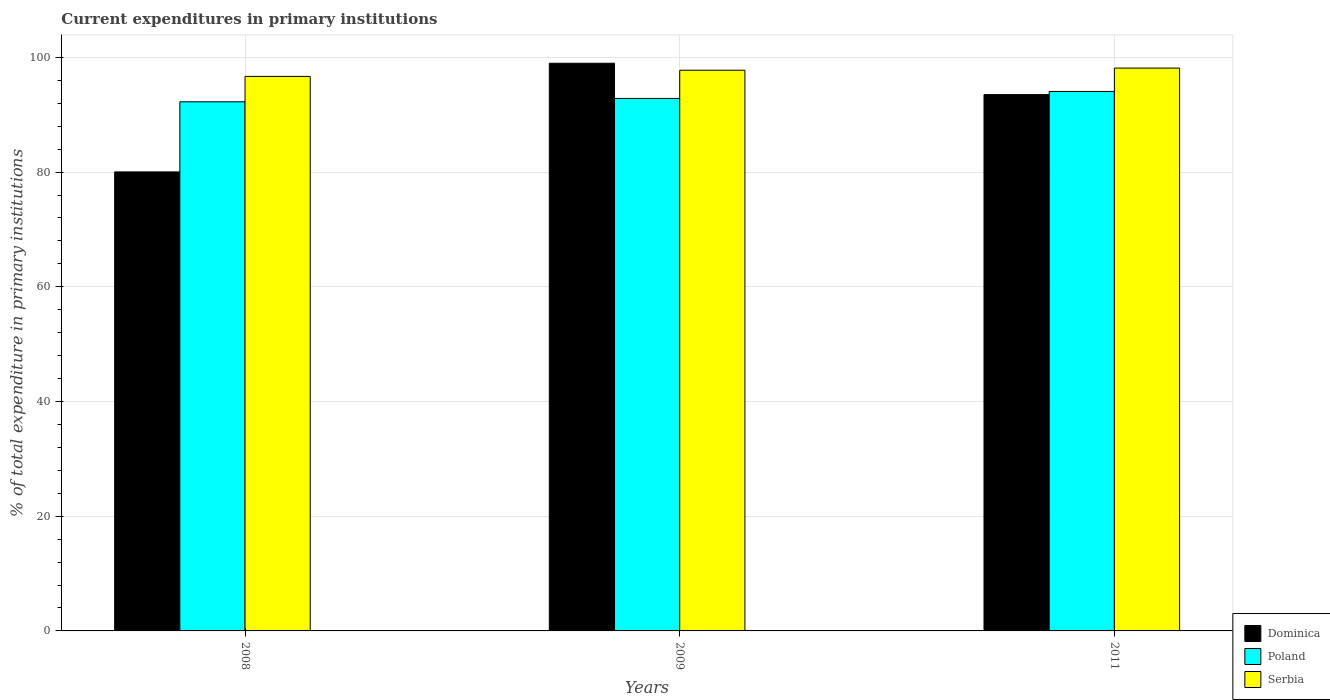How many groups of bars are there?
Your response must be concise. 3. Are the number of bars per tick equal to the number of legend labels?
Keep it short and to the point. Yes. Are the number of bars on each tick of the X-axis equal?
Offer a terse response. Yes. What is the label of the 2nd group of bars from the left?
Keep it short and to the point. 2009. What is the current expenditures in primary institutions in Serbia in 2011?
Offer a very short reply. 98.13. Across all years, what is the maximum current expenditures in primary institutions in Serbia?
Give a very brief answer. 98.13. Across all years, what is the minimum current expenditures in primary institutions in Serbia?
Provide a succinct answer. 96.68. In which year was the current expenditures in primary institutions in Poland maximum?
Make the answer very short. 2011. What is the total current expenditures in primary institutions in Serbia in the graph?
Give a very brief answer. 292.57. What is the difference between the current expenditures in primary institutions in Serbia in 2008 and that in 2011?
Give a very brief answer. -1.45. What is the difference between the current expenditures in primary institutions in Serbia in 2011 and the current expenditures in primary institutions in Poland in 2009?
Give a very brief answer. 5.29. What is the average current expenditures in primary institutions in Serbia per year?
Make the answer very short. 97.52. In the year 2009, what is the difference between the current expenditures in primary institutions in Serbia and current expenditures in primary institutions in Dominica?
Offer a very short reply. -1.22. In how many years, is the current expenditures in primary institutions in Poland greater than 76 %?
Ensure brevity in your answer.  3. What is the ratio of the current expenditures in primary institutions in Poland in 2009 to that in 2011?
Your answer should be compact. 0.99. What is the difference between the highest and the second highest current expenditures in primary institutions in Serbia?
Your response must be concise. 0.37. What is the difference between the highest and the lowest current expenditures in primary institutions in Poland?
Your response must be concise. 1.8. In how many years, is the current expenditures in primary institutions in Poland greater than the average current expenditures in primary institutions in Poland taken over all years?
Your answer should be very brief. 1. What does the 3rd bar from the left in 2008 represents?
Your answer should be compact. Serbia. What does the 1st bar from the right in 2008 represents?
Provide a succinct answer. Serbia. How many years are there in the graph?
Give a very brief answer. 3. Does the graph contain any zero values?
Ensure brevity in your answer.  No. Where does the legend appear in the graph?
Offer a terse response. Bottom right. What is the title of the graph?
Keep it short and to the point. Current expenditures in primary institutions. What is the label or title of the Y-axis?
Offer a very short reply. % of total expenditure in primary institutions. What is the % of total expenditure in primary institutions in Dominica in 2008?
Make the answer very short. 80.03. What is the % of total expenditure in primary institutions in Poland in 2008?
Give a very brief answer. 92.25. What is the % of total expenditure in primary institutions of Serbia in 2008?
Ensure brevity in your answer.  96.68. What is the % of total expenditure in primary institutions in Dominica in 2009?
Your response must be concise. 98.97. What is the % of total expenditure in primary institutions of Poland in 2009?
Offer a terse response. 92.84. What is the % of total expenditure in primary institutions in Serbia in 2009?
Provide a short and direct response. 97.76. What is the % of total expenditure in primary institutions of Dominica in 2011?
Offer a very short reply. 93.5. What is the % of total expenditure in primary institutions of Poland in 2011?
Your response must be concise. 94.06. What is the % of total expenditure in primary institutions in Serbia in 2011?
Ensure brevity in your answer.  98.13. Across all years, what is the maximum % of total expenditure in primary institutions of Dominica?
Make the answer very short. 98.97. Across all years, what is the maximum % of total expenditure in primary institutions of Poland?
Offer a terse response. 94.06. Across all years, what is the maximum % of total expenditure in primary institutions in Serbia?
Keep it short and to the point. 98.13. Across all years, what is the minimum % of total expenditure in primary institutions of Dominica?
Your answer should be very brief. 80.03. Across all years, what is the minimum % of total expenditure in primary institutions of Poland?
Provide a succinct answer. 92.25. Across all years, what is the minimum % of total expenditure in primary institutions of Serbia?
Give a very brief answer. 96.68. What is the total % of total expenditure in primary institutions in Dominica in the graph?
Keep it short and to the point. 272.5. What is the total % of total expenditure in primary institutions in Poland in the graph?
Your answer should be compact. 279.15. What is the total % of total expenditure in primary institutions of Serbia in the graph?
Keep it short and to the point. 292.57. What is the difference between the % of total expenditure in primary institutions of Dominica in 2008 and that in 2009?
Make the answer very short. -18.94. What is the difference between the % of total expenditure in primary institutions in Poland in 2008 and that in 2009?
Make the answer very short. -0.58. What is the difference between the % of total expenditure in primary institutions in Serbia in 2008 and that in 2009?
Keep it short and to the point. -1.08. What is the difference between the % of total expenditure in primary institutions in Dominica in 2008 and that in 2011?
Keep it short and to the point. -13.48. What is the difference between the % of total expenditure in primary institutions of Poland in 2008 and that in 2011?
Offer a very short reply. -1.8. What is the difference between the % of total expenditure in primary institutions in Serbia in 2008 and that in 2011?
Provide a short and direct response. -1.45. What is the difference between the % of total expenditure in primary institutions in Dominica in 2009 and that in 2011?
Ensure brevity in your answer.  5.47. What is the difference between the % of total expenditure in primary institutions of Poland in 2009 and that in 2011?
Provide a succinct answer. -1.22. What is the difference between the % of total expenditure in primary institutions of Serbia in 2009 and that in 2011?
Give a very brief answer. -0.37. What is the difference between the % of total expenditure in primary institutions of Dominica in 2008 and the % of total expenditure in primary institutions of Poland in 2009?
Provide a short and direct response. -12.81. What is the difference between the % of total expenditure in primary institutions of Dominica in 2008 and the % of total expenditure in primary institutions of Serbia in 2009?
Provide a short and direct response. -17.73. What is the difference between the % of total expenditure in primary institutions of Poland in 2008 and the % of total expenditure in primary institutions of Serbia in 2009?
Keep it short and to the point. -5.5. What is the difference between the % of total expenditure in primary institutions in Dominica in 2008 and the % of total expenditure in primary institutions in Poland in 2011?
Give a very brief answer. -14.03. What is the difference between the % of total expenditure in primary institutions in Dominica in 2008 and the % of total expenditure in primary institutions in Serbia in 2011?
Ensure brevity in your answer.  -18.1. What is the difference between the % of total expenditure in primary institutions in Poland in 2008 and the % of total expenditure in primary institutions in Serbia in 2011?
Offer a very short reply. -5.88. What is the difference between the % of total expenditure in primary institutions in Dominica in 2009 and the % of total expenditure in primary institutions in Poland in 2011?
Ensure brevity in your answer.  4.91. What is the difference between the % of total expenditure in primary institutions in Dominica in 2009 and the % of total expenditure in primary institutions in Serbia in 2011?
Your response must be concise. 0.84. What is the difference between the % of total expenditure in primary institutions in Poland in 2009 and the % of total expenditure in primary institutions in Serbia in 2011?
Your response must be concise. -5.29. What is the average % of total expenditure in primary institutions of Dominica per year?
Your response must be concise. 90.83. What is the average % of total expenditure in primary institutions of Poland per year?
Ensure brevity in your answer.  93.05. What is the average % of total expenditure in primary institutions in Serbia per year?
Provide a short and direct response. 97.52. In the year 2008, what is the difference between the % of total expenditure in primary institutions of Dominica and % of total expenditure in primary institutions of Poland?
Offer a very short reply. -12.22. In the year 2008, what is the difference between the % of total expenditure in primary institutions of Dominica and % of total expenditure in primary institutions of Serbia?
Provide a short and direct response. -16.65. In the year 2008, what is the difference between the % of total expenditure in primary institutions in Poland and % of total expenditure in primary institutions in Serbia?
Provide a succinct answer. -4.43. In the year 2009, what is the difference between the % of total expenditure in primary institutions of Dominica and % of total expenditure in primary institutions of Poland?
Keep it short and to the point. 6.13. In the year 2009, what is the difference between the % of total expenditure in primary institutions in Dominica and % of total expenditure in primary institutions in Serbia?
Provide a short and direct response. 1.22. In the year 2009, what is the difference between the % of total expenditure in primary institutions of Poland and % of total expenditure in primary institutions of Serbia?
Your answer should be compact. -4.92. In the year 2011, what is the difference between the % of total expenditure in primary institutions in Dominica and % of total expenditure in primary institutions in Poland?
Your response must be concise. -0.55. In the year 2011, what is the difference between the % of total expenditure in primary institutions in Dominica and % of total expenditure in primary institutions in Serbia?
Keep it short and to the point. -4.62. In the year 2011, what is the difference between the % of total expenditure in primary institutions of Poland and % of total expenditure in primary institutions of Serbia?
Provide a short and direct response. -4.07. What is the ratio of the % of total expenditure in primary institutions of Dominica in 2008 to that in 2009?
Ensure brevity in your answer.  0.81. What is the ratio of the % of total expenditure in primary institutions of Serbia in 2008 to that in 2009?
Provide a succinct answer. 0.99. What is the ratio of the % of total expenditure in primary institutions in Dominica in 2008 to that in 2011?
Your response must be concise. 0.86. What is the ratio of the % of total expenditure in primary institutions in Poland in 2008 to that in 2011?
Provide a short and direct response. 0.98. What is the ratio of the % of total expenditure in primary institutions in Serbia in 2008 to that in 2011?
Offer a terse response. 0.99. What is the ratio of the % of total expenditure in primary institutions of Dominica in 2009 to that in 2011?
Offer a terse response. 1.06. What is the ratio of the % of total expenditure in primary institutions of Poland in 2009 to that in 2011?
Your answer should be very brief. 0.99. What is the ratio of the % of total expenditure in primary institutions in Serbia in 2009 to that in 2011?
Give a very brief answer. 1. What is the difference between the highest and the second highest % of total expenditure in primary institutions in Dominica?
Offer a very short reply. 5.47. What is the difference between the highest and the second highest % of total expenditure in primary institutions of Poland?
Provide a short and direct response. 1.22. What is the difference between the highest and the second highest % of total expenditure in primary institutions in Serbia?
Your answer should be compact. 0.37. What is the difference between the highest and the lowest % of total expenditure in primary institutions in Dominica?
Offer a very short reply. 18.94. What is the difference between the highest and the lowest % of total expenditure in primary institutions of Poland?
Your answer should be compact. 1.8. What is the difference between the highest and the lowest % of total expenditure in primary institutions of Serbia?
Provide a short and direct response. 1.45. 